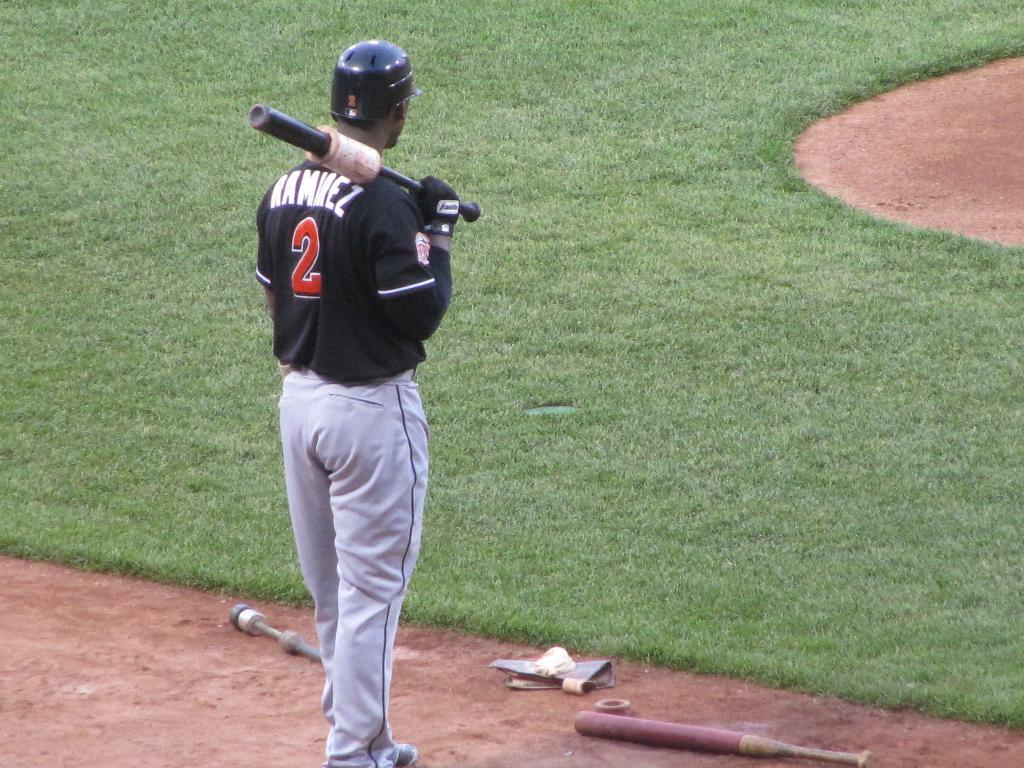<image>
Create a compact narrative representing the image presented. A baseball player with the name Ramirez holding a bat. 